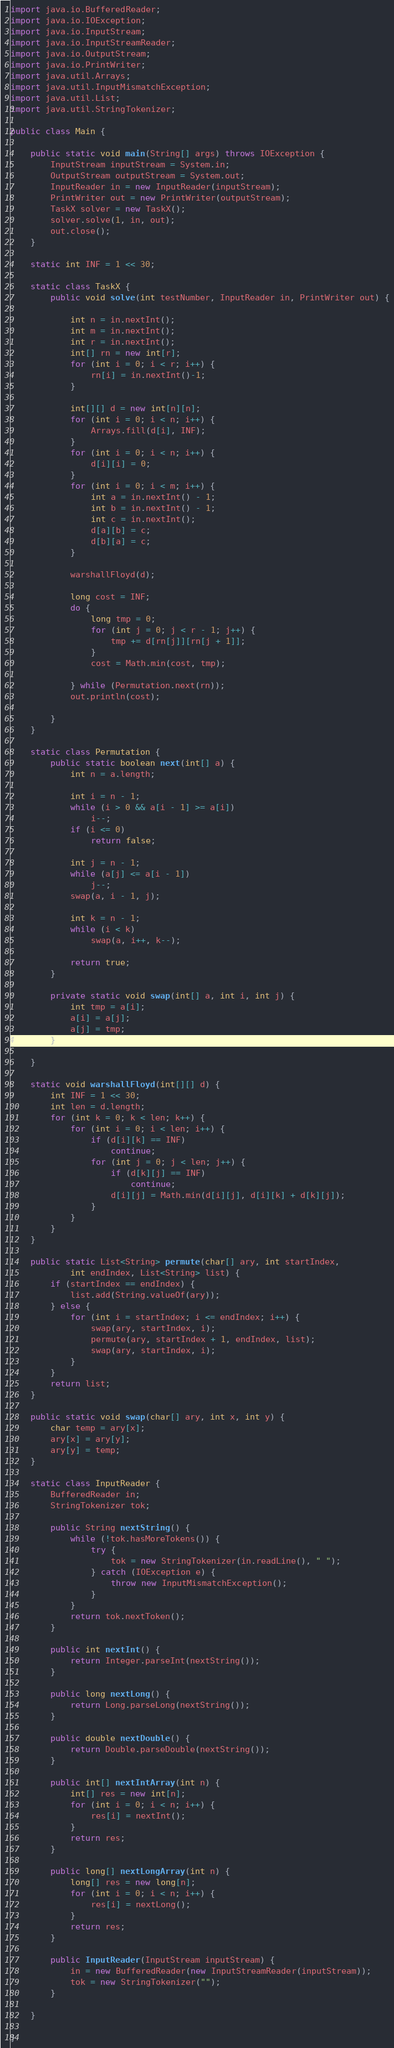<code> <loc_0><loc_0><loc_500><loc_500><_Java_>
import java.io.BufferedReader;
import java.io.IOException;
import java.io.InputStream;
import java.io.InputStreamReader;
import java.io.OutputStream;
import java.io.PrintWriter;
import java.util.Arrays;
import java.util.InputMismatchException;
import java.util.List;
import java.util.StringTokenizer;

public class Main {

	public static void main(String[] args) throws IOException {
		InputStream inputStream = System.in;
		OutputStream outputStream = System.out;
		InputReader in = new InputReader(inputStream);
		PrintWriter out = new PrintWriter(outputStream);
		TaskX solver = new TaskX();
		solver.solve(1, in, out);
		out.close();
	}

	static int INF = 1 << 30;

	static class TaskX {
		public void solve(int testNumber, InputReader in, PrintWriter out) {

			int n = in.nextInt();
			int m = in.nextInt();
			int r = in.nextInt();
			int[] rn = new int[r];
			for (int i = 0; i < r; i++) {
				rn[i] = in.nextInt()-1;
			}

			int[][] d = new int[n][n];
			for (int i = 0; i < n; i++) {
				Arrays.fill(d[i], INF);
			}
			for (int i = 0; i < n; i++) {
				d[i][i] = 0;
			}
			for (int i = 0; i < m; i++) {
				int a = in.nextInt() - 1;
				int b = in.nextInt() - 1;
				int c = in.nextInt();
				d[a][b] = c;
				d[b][a] = c;
			}

			warshallFloyd(d);

			long cost = INF;
			do {
				long tmp = 0;
				for (int j = 0; j < r - 1; j++) {
					tmp += d[rn[j]][rn[j + 1]];
				}
				cost = Math.min(cost, tmp);

			} while (Permutation.next(rn));
			out.println(cost);

		}
	}

	static class Permutation {
		public static boolean next(int[] a) {
			int n = a.length;

			int i = n - 1;
			while (i > 0 && a[i - 1] >= a[i])
				i--;
			if (i <= 0)
				return false;

			int j = n - 1;
			while (a[j] <= a[i - 1])
				j--;
			swap(a, i - 1, j);

			int k = n - 1;
			while (i < k)
				swap(a, i++, k--);

			return true;
		}

		private static void swap(int[] a, int i, int j) {
			int tmp = a[i];
			a[i] = a[j];
			a[j] = tmp;
		}

	}

	static void warshallFloyd(int[][] d) {
		int INF = 1 << 30;
		int len = d.length;
		for (int k = 0; k < len; k++) {
			for (int i = 0; i < len; i++) {
				if (d[i][k] == INF)
					continue;
				for (int j = 0; j < len; j++) {
					if (d[k][j] == INF)
						continue;
					d[i][j] = Math.min(d[i][j], d[i][k] + d[k][j]);
				}
			}
		}
	}

	public static List<String> permute(char[] ary, int startIndex,
			int endIndex, List<String> list) {
		if (startIndex == endIndex) {
			list.add(String.valueOf(ary));
		} else {
			for (int i = startIndex; i <= endIndex; i++) {
				swap(ary, startIndex, i);
				permute(ary, startIndex + 1, endIndex, list);
				swap(ary, startIndex, i);
			}
		}
		return list;
	}

	public static void swap(char[] ary, int x, int y) {
		char temp = ary[x];
		ary[x] = ary[y];
		ary[y] = temp;
	}

	static class InputReader {
		BufferedReader in;
		StringTokenizer tok;

		public String nextString() {
			while (!tok.hasMoreTokens()) {
				try {
					tok = new StringTokenizer(in.readLine(), " ");
				} catch (IOException e) {
					throw new InputMismatchException();
				}
			}
			return tok.nextToken();
		}

		public int nextInt() {
			return Integer.parseInt(nextString());
		}

		public long nextLong() {
			return Long.parseLong(nextString());
		}

		public double nextDouble() {
			return Double.parseDouble(nextString());
		}

		public int[] nextIntArray(int n) {
			int[] res = new int[n];
			for (int i = 0; i < n; i++) {
				res[i] = nextInt();
			}
			return res;
		}

		public long[] nextLongArray(int n) {
			long[] res = new long[n];
			for (int i = 0; i < n; i++) {
				res[i] = nextLong();
			}
			return res;
		}

		public InputReader(InputStream inputStream) {
			in = new BufferedReader(new InputStreamReader(inputStream));
			tok = new StringTokenizer("");
		}

	}

}
</code> 